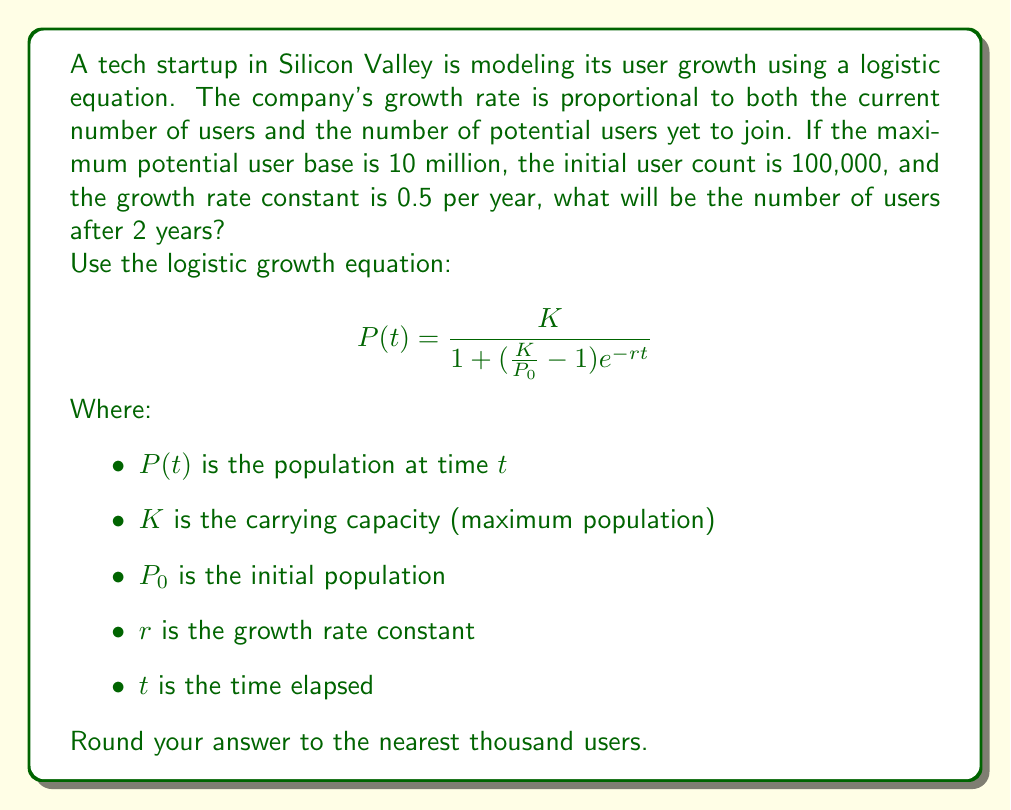Help me with this question. To solve this problem, we'll use the given logistic growth equation and plug in the values provided:

$K = 10,000,000$ (maximum potential users)
$P_0 = 100,000$ (initial users)
$r = 0.5$ (growth rate constant per year)
$t = 2$ (years elapsed)

Let's substitute these values into the equation:

$$P(2) = \frac{10,000,000}{1 + (\frac{10,000,000}{100,000} - 1)e^{-0.5 \cdot 2}}$$

Now, let's solve this step by step:

1. Simplify the fraction inside the parentheses:
   $$\frac{10,000,000}{100,000} - 1 = 100 - 1 = 99$$

2. Calculate the exponential term:
   $$e^{-0.5 \cdot 2} = e^{-1} \approx 0.3679$$

3. Multiply the results from steps 1 and 2:
   $$99 \cdot 0.3679 \approx 36.4221$$

4. Add 1 to the result from step 3:
   $$1 + 36.4221 \approx 37.4221$$

5. Divide the carrying capacity by the result from step 4:
   $$\frac{10,000,000}{37.4221} \approx 267,220.8$$

6. Round to the nearest thousand:
   $$267,220.8 \approx 267,000$$

Therefore, after 2 years, the number of users will be approximately 267,000.
Answer: 267,000 users 